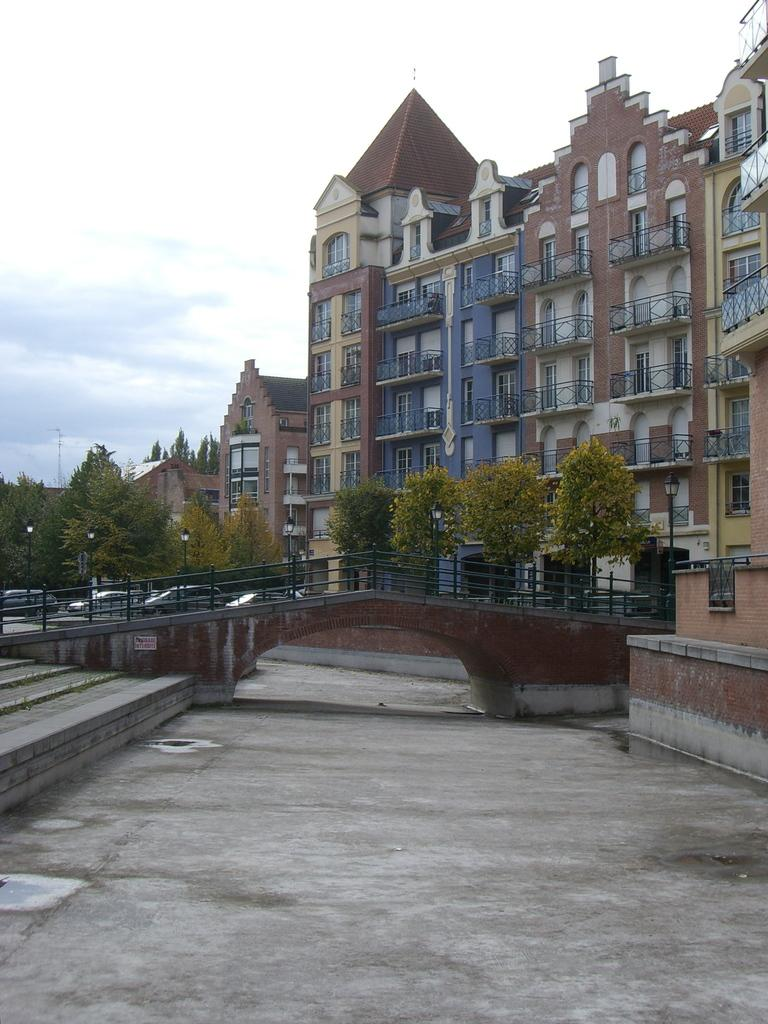What is visible at the bottom of the image? Ground is visible at the bottom of the image. What structure can be seen in the image? There is a bridge in the image. What type of barriers are present in the image? Fences are present in the image. What type of natural elements can be seen in the image? Trees are visible in the image. What can be seen in the background of the image? Vehicles, buildings, fences, trees, poles, and clouds are visible in the background of the image. How much money is being exchanged between the trees in the image? There is no money being exchanged in the image, as it features a bridge, trees, and other elements, but no financial transactions. 